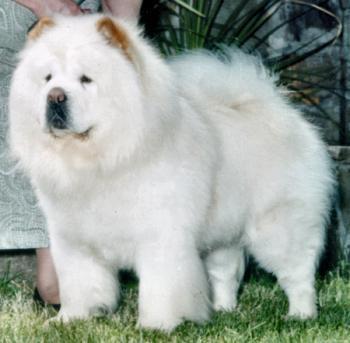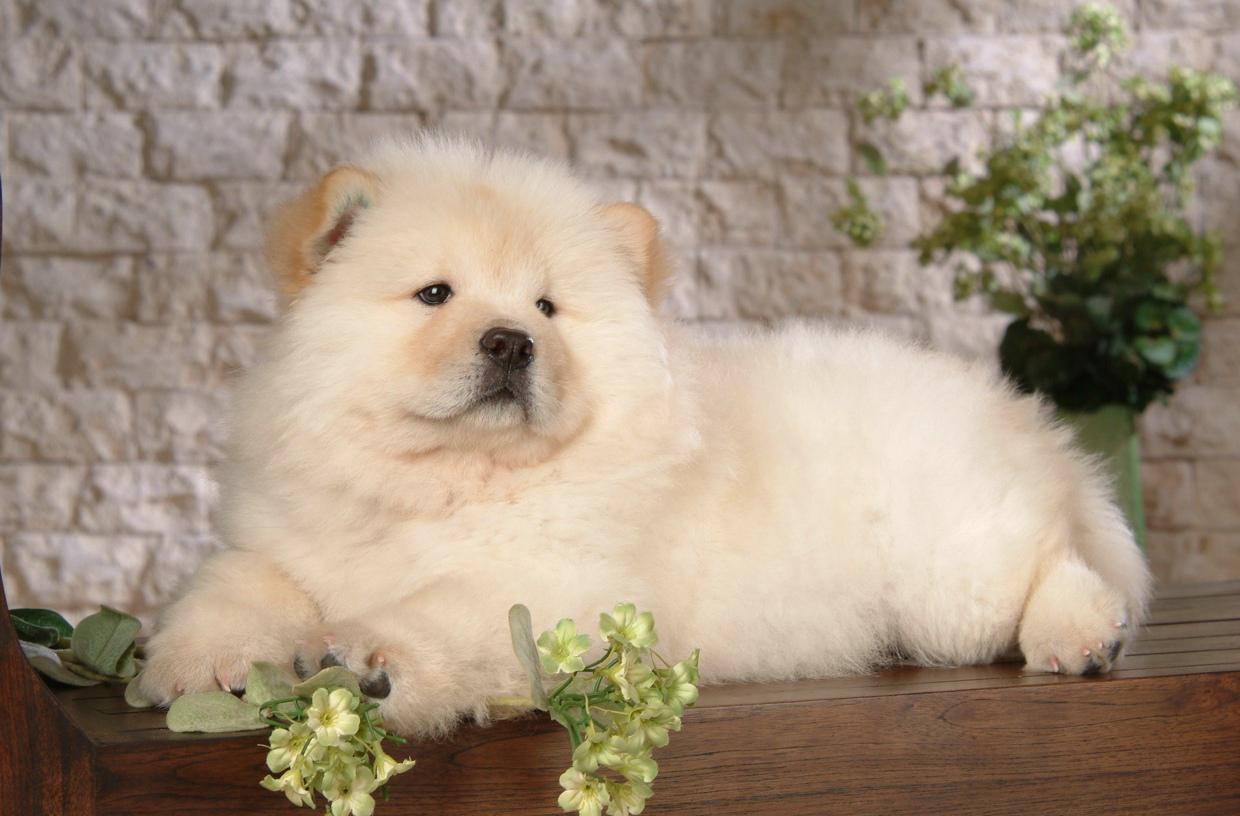The first image is the image on the left, the second image is the image on the right. For the images shown, is this caption "At least two dogs have their mouths open." true? Answer yes or no. No. The first image is the image on the left, the second image is the image on the right. Given the left and right images, does the statement "The left image features a left-turned pale-colored chow standing in front of a person." hold true? Answer yes or no. Yes. 